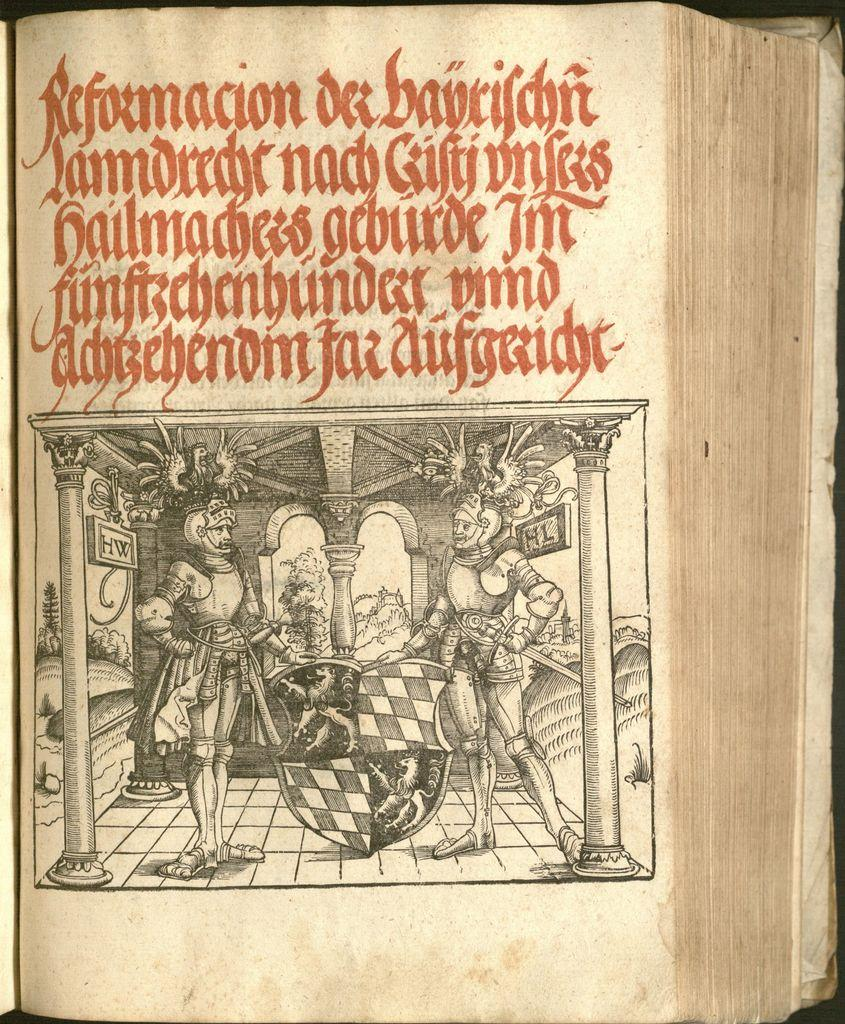<image>
Write a terse but informative summary of the picture. A page from an old book shows 2 figures in knight's armour and red writing about "Reformacion" in Spanish. 